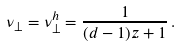Convert formula to latex. <formula><loc_0><loc_0><loc_500><loc_500>\nu _ { \perp } = \nu _ { \perp } ^ { h } = \frac { 1 } { ( d - 1 ) z + 1 } \, .</formula> 